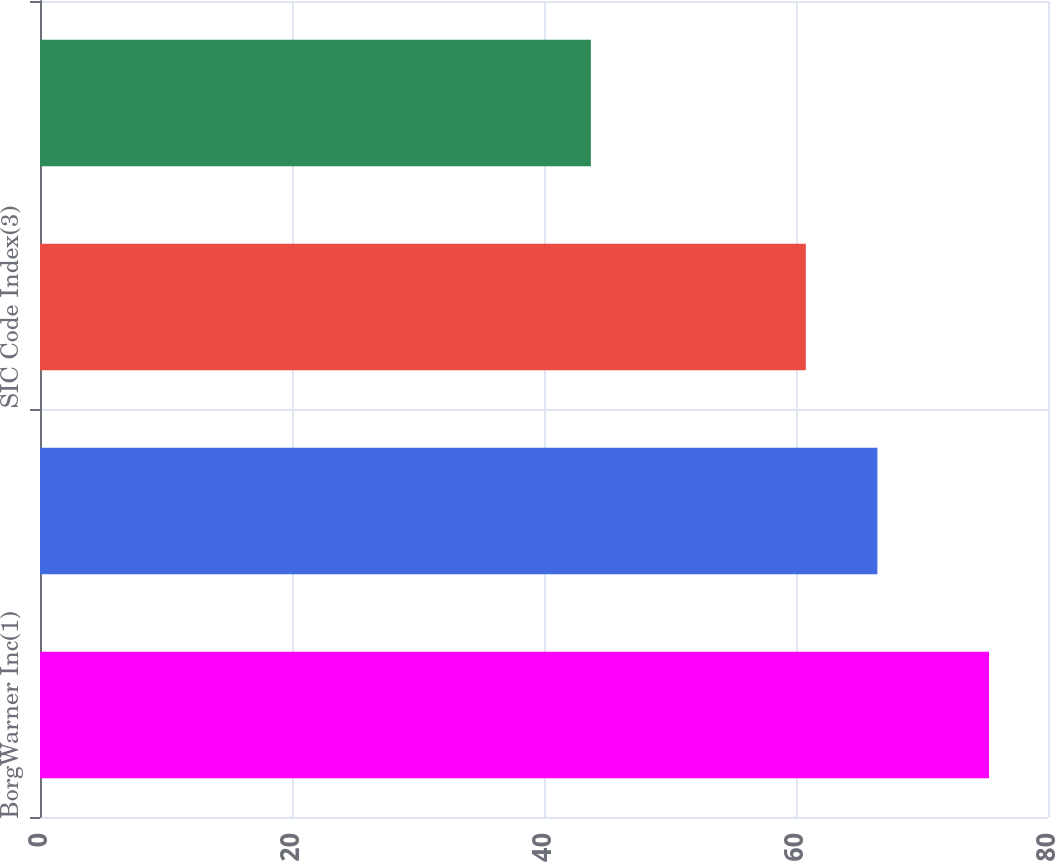<chart> <loc_0><loc_0><loc_500><loc_500><bar_chart><fcel>BorgWarner Inc(1)<fcel>S&P 500(2)<fcel>SIC Code Index(3)<fcel>Peer Group(4)<nl><fcel>75.32<fcel>66.46<fcel>60.78<fcel>43.72<nl></chart> 